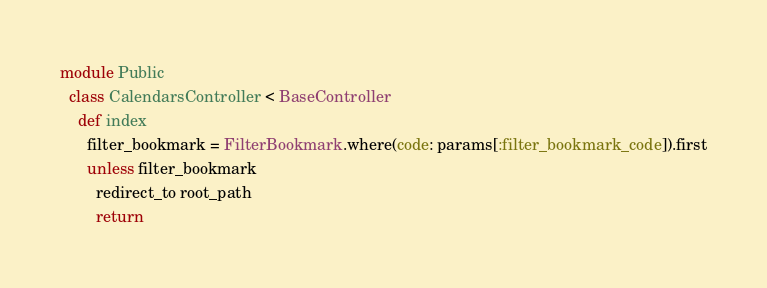<code> <loc_0><loc_0><loc_500><loc_500><_Ruby_>module Public
  class CalendarsController < BaseController
    def index
      filter_bookmark = FilterBookmark.where(code: params[:filter_bookmark_code]).first
      unless filter_bookmark
        redirect_to root_path
        return</code> 